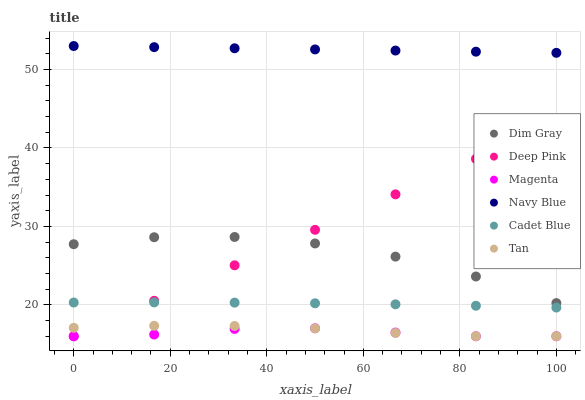Does Magenta have the minimum area under the curve?
Answer yes or no. Yes. Does Navy Blue have the maximum area under the curve?
Answer yes or no. Yes. Does Deep Pink have the minimum area under the curve?
Answer yes or no. No. Does Deep Pink have the maximum area under the curve?
Answer yes or no. No. Is Navy Blue the smoothest?
Answer yes or no. Yes. Is Dim Gray the roughest?
Answer yes or no. Yes. Is Deep Pink the smoothest?
Answer yes or no. No. Is Deep Pink the roughest?
Answer yes or no. No. Does Deep Pink have the lowest value?
Answer yes or no. Yes. Does Navy Blue have the lowest value?
Answer yes or no. No. Does Navy Blue have the highest value?
Answer yes or no. Yes. Does Deep Pink have the highest value?
Answer yes or no. No. Is Magenta less than Navy Blue?
Answer yes or no. Yes. Is Navy Blue greater than Magenta?
Answer yes or no. Yes. Does Deep Pink intersect Magenta?
Answer yes or no. Yes. Is Deep Pink less than Magenta?
Answer yes or no. No. Is Deep Pink greater than Magenta?
Answer yes or no. No. Does Magenta intersect Navy Blue?
Answer yes or no. No. 